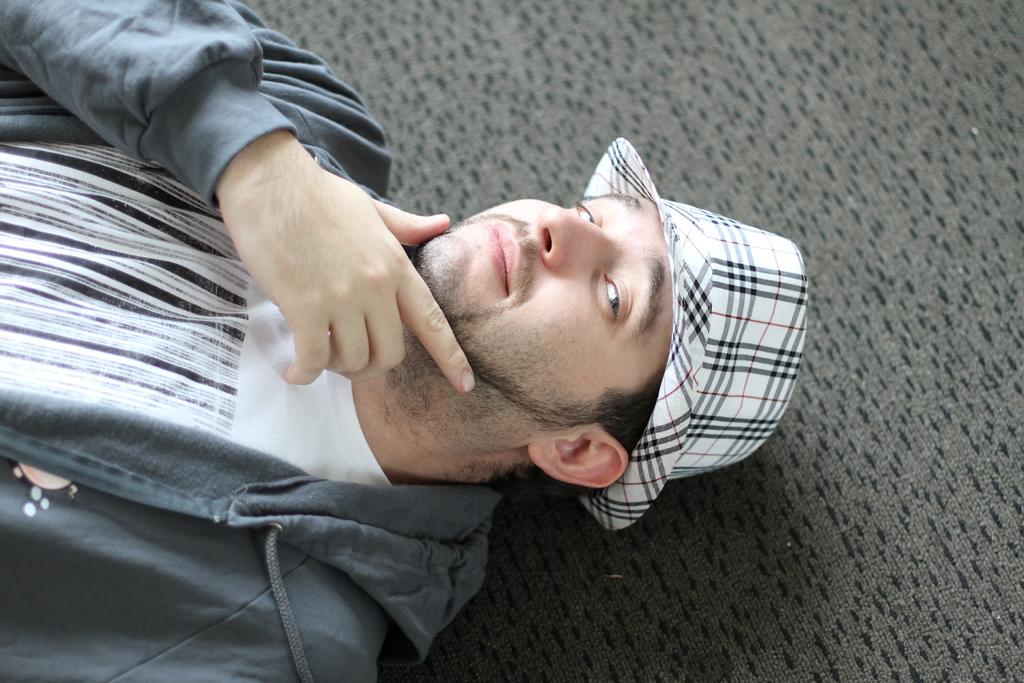What is present in the image? There is a man in the image. Can you describe the man's attire? The man is wearing a hat. What can be seen in the background of the image? There is a gray color surface in the background of the image. What type of bells can be heard ringing in the image? There are no bells present in the image, and therefore no such sound can be heard. How does the gray color surface in the background of the image increase in size? The gray color surface in the background of the image does not increase in size; it is a static image. 